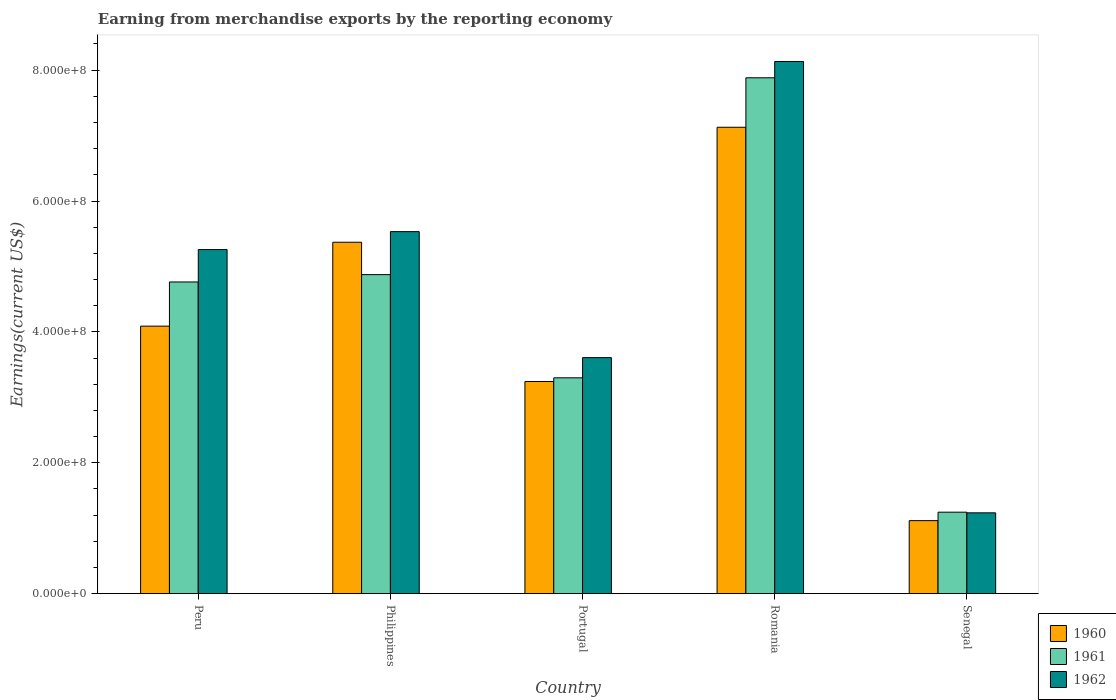Are the number of bars on each tick of the X-axis equal?
Make the answer very short. Yes. How many bars are there on the 2nd tick from the right?
Your answer should be very brief. 3. In how many cases, is the number of bars for a given country not equal to the number of legend labels?
Provide a succinct answer. 0. What is the amount earned from merchandise exports in 1962 in Senegal?
Your answer should be very brief. 1.24e+08. Across all countries, what is the maximum amount earned from merchandise exports in 1961?
Provide a short and direct response. 7.88e+08. Across all countries, what is the minimum amount earned from merchandise exports in 1962?
Your answer should be compact. 1.24e+08. In which country was the amount earned from merchandise exports in 1961 maximum?
Keep it short and to the point. Romania. In which country was the amount earned from merchandise exports in 1962 minimum?
Make the answer very short. Senegal. What is the total amount earned from merchandise exports in 1962 in the graph?
Ensure brevity in your answer.  2.38e+09. What is the difference between the amount earned from merchandise exports in 1960 in Peru and that in Portugal?
Give a very brief answer. 8.46e+07. What is the difference between the amount earned from merchandise exports in 1961 in Peru and the amount earned from merchandise exports in 1962 in Romania?
Give a very brief answer. -3.37e+08. What is the average amount earned from merchandise exports in 1961 per country?
Your answer should be compact. 4.41e+08. What is the difference between the amount earned from merchandise exports of/in 1960 and amount earned from merchandise exports of/in 1961 in Senegal?
Make the answer very short. -1.29e+07. In how many countries, is the amount earned from merchandise exports in 1960 greater than 520000000 US$?
Provide a succinct answer. 2. What is the ratio of the amount earned from merchandise exports in 1962 in Peru to that in Senegal?
Provide a succinct answer. 4.26. Is the amount earned from merchandise exports in 1960 in Peru less than that in Senegal?
Your answer should be very brief. No. Is the difference between the amount earned from merchandise exports in 1960 in Peru and Romania greater than the difference between the amount earned from merchandise exports in 1961 in Peru and Romania?
Ensure brevity in your answer.  Yes. What is the difference between the highest and the second highest amount earned from merchandise exports in 1962?
Provide a succinct answer. 2.87e+08. What is the difference between the highest and the lowest amount earned from merchandise exports in 1962?
Your answer should be very brief. 6.90e+08. In how many countries, is the amount earned from merchandise exports in 1961 greater than the average amount earned from merchandise exports in 1961 taken over all countries?
Give a very brief answer. 3. Is the sum of the amount earned from merchandise exports in 1962 in Peru and Senegal greater than the maximum amount earned from merchandise exports in 1960 across all countries?
Provide a short and direct response. No. What does the 3rd bar from the right in Peru represents?
Your answer should be very brief. 1960. Is it the case that in every country, the sum of the amount earned from merchandise exports in 1962 and amount earned from merchandise exports in 1960 is greater than the amount earned from merchandise exports in 1961?
Offer a very short reply. Yes. Are all the bars in the graph horizontal?
Provide a short and direct response. No. How many countries are there in the graph?
Ensure brevity in your answer.  5. Are the values on the major ticks of Y-axis written in scientific E-notation?
Offer a very short reply. Yes. Does the graph contain any zero values?
Provide a short and direct response. No. Where does the legend appear in the graph?
Your answer should be very brief. Bottom right. How many legend labels are there?
Provide a short and direct response. 3. How are the legend labels stacked?
Provide a succinct answer. Vertical. What is the title of the graph?
Offer a terse response. Earning from merchandise exports by the reporting economy. Does "2012" appear as one of the legend labels in the graph?
Your response must be concise. No. What is the label or title of the X-axis?
Your answer should be compact. Country. What is the label or title of the Y-axis?
Give a very brief answer. Earnings(current US$). What is the Earnings(current US$) in 1960 in Peru?
Your answer should be compact. 4.09e+08. What is the Earnings(current US$) of 1961 in Peru?
Make the answer very short. 4.76e+08. What is the Earnings(current US$) of 1962 in Peru?
Your answer should be compact. 5.26e+08. What is the Earnings(current US$) of 1960 in Philippines?
Your answer should be very brief. 5.37e+08. What is the Earnings(current US$) in 1961 in Philippines?
Provide a short and direct response. 4.88e+08. What is the Earnings(current US$) in 1962 in Philippines?
Give a very brief answer. 5.53e+08. What is the Earnings(current US$) in 1960 in Portugal?
Offer a very short reply. 3.24e+08. What is the Earnings(current US$) of 1961 in Portugal?
Make the answer very short. 3.30e+08. What is the Earnings(current US$) of 1962 in Portugal?
Keep it short and to the point. 3.61e+08. What is the Earnings(current US$) in 1960 in Romania?
Offer a very short reply. 7.13e+08. What is the Earnings(current US$) in 1961 in Romania?
Provide a succinct answer. 7.88e+08. What is the Earnings(current US$) in 1962 in Romania?
Ensure brevity in your answer.  8.13e+08. What is the Earnings(current US$) of 1960 in Senegal?
Make the answer very short. 1.12e+08. What is the Earnings(current US$) in 1961 in Senegal?
Offer a very short reply. 1.24e+08. What is the Earnings(current US$) in 1962 in Senegal?
Your answer should be very brief. 1.24e+08. Across all countries, what is the maximum Earnings(current US$) of 1960?
Offer a very short reply. 7.13e+08. Across all countries, what is the maximum Earnings(current US$) in 1961?
Provide a short and direct response. 7.88e+08. Across all countries, what is the maximum Earnings(current US$) in 1962?
Provide a succinct answer. 8.13e+08. Across all countries, what is the minimum Earnings(current US$) in 1960?
Make the answer very short. 1.12e+08. Across all countries, what is the minimum Earnings(current US$) of 1961?
Your response must be concise. 1.24e+08. Across all countries, what is the minimum Earnings(current US$) of 1962?
Offer a very short reply. 1.24e+08. What is the total Earnings(current US$) of 1960 in the graph?
Offer a very short reply. 2.09e+09. What is the total Earnings(current US$) of 1961 in the graph?
Your answer should be compact. 2.21e+09. What is the total Earnings(current US$) of 1962 in the graph?
Make the answer very short. 2.38e+09. What is the difference between the Earnings(current US$) of 1960 in Peru and that in Philippines?
Ensure brevity in your answer.  -1.28e+08. What is the difference between the Earnings(current US$) in 1961 in Peru and that in Philippines?
Provide a succinct answer. -1.12e+07. What is the difference between the Earnings(current US$) of 1962 in Peru and that in Philippines?
Your response must be concise. -2.74e+07. What is the difference between the Earnings(current US$) in 1960 in Peru and that in Portugal?
Ensure brevity in your answer.  8.46e+07. What is the difference between the Earnings(current US$) in 1961 in Peru and that in Portugal?
Your response must be concise. 1.46e+08. What is the difference between the Earnings(current US$) in 1962 in Peru and that in Portugal?
Your answer should be compact. 1.65e+08. What is the difference between the Earnings(current US$) of 1960 in Peru and that in Romania?
Your answer should be compact. -3.04e+08. What is the difference between the Earnings(current US$) of 1961 in Peru and that in Romania?
Offer a very short reply. -3.12e+08. What is the difference between the Earnings(current US$) of 1962 in Peru and that in Romania?
Keep it short and to the point. -2.87e+08. What is the difference between the Earnings(current US$) of 1960 in Peru and that in Senegal?
Your answer should be compact. 2.97e+08. What is the difference between the Earnings(current US$) in 1961 in Peru and that in Senegal?
Your answer should be very brief. 3.52e+08. What is the difference between the Earnings(current US$) in 1962 in Peru and that in Senegal?
Ensure brevity in your answer.  4.02e+08. What is the difference between the Earnings(current US$) in 1960 in Philippines and that in Portugal?
Offer a very short reply. 2.13e+08. What is the difference between the Earnings(current US$) in 1961 in Philippines and that in Portugal?
Keep it short and to the point. 1.58e+08. What is the difference between the Earnings(current US$) in 1962 in Philippines and that in Portugal?
Offer a very short reply. 1.93e+08. What is the difference between the Earnings(current US$) of 1960 in Philippines and that in Romania?
Make the answer very short. -1.76e+08. What is the difference between the Earnings(current US$) in 1961 in Philippines and that in Romania?
Provide a short and direct response. -3.01e+08. What is the difference between the Earnings(current US$) of 1962 in Philippines and that in Romania?
Your response must be concise. -2.60e+08. What is the difference between the Earnings(current US$) of 1960 in Philippines and that in Senegal?
Ensure brevity in your answer.  4.25e+08. What is the difference between the Earnings(current US$) of 1961 in Philippines and that in Senegal?
Provide a succinct answer. 3.63e+08. What is the difference between the Earnings(current US$) in 1962 in Philippines and that in Senegal?
Keep it short and to the point. 4.30e+08. What is the difference between the Earnings(current US$) in 1960 in Portugal and that in Romania?
Provide a succinct answer. -3.89e+08. What is the difference between the Earnings(current US$) of 1961 in Portugal and that in Romania?
Your response must be concise. -4.58e+08. What is the difference between the Earnings(current US$) in 1962 in Portugal and that in Romania?
Provide a short and direct response. -4.53e+08. What is the difference between the Earnings(current US$) of 1960 in Portugal and that in Senegal?
Ensure brevity in your answer.  2.13e+08. What is the difference between the Earnings(current US$) of 1961 in Portugal and that in Senegal?
Your answer should be compact. 2.05e+08. What is the difference between the Earnings(current US$) in 1962 in Portugal and that in Senegal?
Offer a terse response. 2.37e+08. What is the difference between the Earnings(current US$) in 1960 in Romania and that in Senegal?
Your answer should be compact. 6.01e+08. What is the difference between the Earnings(current US$) of 1961 in Romania and that in Senegal?
Give a very brief answer. 6.64e+08. What is the difference between the Earnings(current US$) of 1962 in Romania and that in Senegal?
Your answer should be compact. 6.90e+08. What is the difference between the Earnings(current US$) of 1960 in Peru and the Earnings(current US$) of 1961 in Philippines?
Provide a succinct answer. -7.87e+07. What is the difference between the Earnings(current US$) in 1960 in Peru and the Earnings(current US$) in 1962 in Philippines?
Make the answer very short. -1.44e+08. What is the difference between the Earnings(current US$) of 1961 in Peru and the Earnings(current US$) of 1962 in Philippines?
Your answer should be very brief. -7.69e+07. What is the difference between the Earnings(current US$) of 1960 in Peru and the Earnings(current US$) of 1961 in Portugal?
Your response must be concise. 7.90e+07. What is the difference between the Earnings(current US$) in 1960 in Peru and the Earnings(current US$) in 1962 in Portugal?
Make the answer very short. 4.81e+07. What is the difference between the Earnings(current US$) in 1961 in Peru and the Earnings(current US$) in 1962 in Portugal?
Your answer should be compact. 1.16e+08. What is the difference between the Earnings(current US$) of 1960 in Peru and the Earnings(current US$) of 1961 in Romania?
Provide a succinct answer. -3.79e+08. What is the difference between the Earnings(current US$) of 1960 in Peru and the Earnings(current US$) of 1962 in Romania?
Provide a succinct answer. -4.04e+08. What is the difference between the Earnings(current US$) in 1961 in Peru and the Earnings(current US$) in 1962 in Romania?
Your answer should be very brief. -3.37e+08. What is the difference between the Earnings(current US$) of 1960 in Peru and the Earnings(current US$) of 1961 in Senegal?
Make the answer very short. 2.84e+08. What is the difference between the Earnings(current US$) in 1960 in Peru and the Earnings(current US$) in 1962 in Senegal?
Offer a very short reply. 2.85e+08. What is the difference between the Earnings(current US$) in 1961 in Peru and the Earnings(current US$) in 1962 in Senegal?
Your answer should be compact. 3.53e+08. What is the difference between the Earnings(current US$) in 1960 in Philippines and the Earnings(current US$) in 1961 in Portugal?
Provide a short and direct response. 2.07e+08. What is the difference between the Earnings(current US$) in 1960 in Philippines and the Earnings(current US$) in 1962 in Portugal?
Give a very brief answer. 1.76e+08. What is the difference between the Earnings(current US$) of 1961 in Philippines and the Earnings(current US$) of 1962 in Portugal?
Provide a short and direct response. 1.27e+08. What is the difference between the Earnings(current US$) of 1960 in Philippines and the Earnings(current US$) of 1961 in Romania?
Keep it short and to the point. -2.51e+08. What is the difference between the Earnings(current US$) of 1960 in Philippines and the Earnings(current US$) of 1962 in Romania?
Provide a short and direct response. -2.76e+08. What is the difference between the Earnings(current US$) of 1961 in Philippines and the Earnings(current US$) of 1962 in Romania?
Make the answer very short. -3.26e+08. What is the difference between the Earnings(current US$) of 1960 in Philippines and the Earnings(current US$) of 1961 in Senegal?
Your answer should be very brief. 4.12e+08. What is the difference between the Earnings(current US$) of 1960 in Philippines and the Earnings(current US$) of 1962 in Senegal?
Provide a succinct answer. 4.14e+08. What is the difference between the Earnings(current US$) of 1961 in Philippines and the Earnings(current US$) of 1962 in Senegal?
Ensure brevity in your answer.  3.64e+08. What is the difference between the Earnings(current US$) of 1960 in Portugal and the Earnings(current US$) of 1961 in Romania?
Your response must be concise. -4.64e+08. What is the difference between the Earnings(current US$) of 1960 in Portugal and the Earnings(current US$) of 1962 in Romania?
Make the answer very short. -4.89e+08. What is the difference between the Earnings(current US$) in 1961 in Portugal and the Earnings(current US$) in 1962 in Romania?
Your response must be concise. -4.83e+08. What is the difference between the Earnings(current US$) of 1960 in Portugal and the Earnings(current US$) of 1961 in Senegal?
Give a very brief answer. 2.00e+08. What is the difference between the Earnings(current US$) in 1960 in Portugal and the Earnings(current US$) in 1962 in Senegal?
Keep it short and to the point. 2.01e+08. What is the difference between the Earnings(current US$) in 1961 in Portugal and the Earnings(current US$) in 1962 in Senegal?
Keep it short and to the point. 2.06e+08. What is the difference between the Earnings(current US$) in 1960 in Romania and the Earnings(current US$) in 1961 in Senegal?
Keep it short and to the point. 5.88e+08. What is the difference between the Earnings(current US$) of 1960 in Romania and the Earnings(current US$) of 1962 in Senegal?
Provide a short and direct response. 5.89e+08. What is the difference between the Earnings(current US$) of 1961 in Romania and the Earnings(current US$) of 1962 in Senegal?
Offer a very short reply. 6.65e+08. What is the average Earnings(current US$) in 1960 per country?
Provide a short and direct response. 4.19e+08. What is the average Earnings(current US$) of 1961 per country?
Provide a succinct answer. 4.41e+08. What is the average Earnings(current US$) in 1962 per country?
Provide a short and direct response. 4.75e+08. What is the difference between the Earnings(current US$) of 1960 and Earnings(current US$) of 1961 in Peru?
Your answer should be compact. -6.75e+07. What is the difference between the Earnings(current US$) of 1960 and Earnings(current US$) of 1962 in Peru?
Offer a very short reply. -1.17e+08. What is the difference between the Earnings(current US$) of 1961 and Earnings(current US$) of 1962 in Peru?
Provide a short and direct response. -4.95e+07. What is the difference between the Earnings(current US$) of 1960 and Earnings(current US$) of 1961 in Philippines?
Provide a short and direct response. 4.95e+07. What is the difference between the Earnings(current US$) of 1960 and Earnings(current US$) of 1962 in Philippines?
Provide a succinct answer. -1.62e+07. What is the difference between the Earnings(current US$) of 1961 and Earnings(current US$) of 1962 in Philippines?
Give a very brief answer. -6.57e+07. What is the difference between the Earnings(current US$) of 1960 and Earnings(current US$) of 1961 in Portugal?
Make the answer very short. -5.62e+06. What is the difference between the Earnings(current US$) in 1960 and Earnings(current US$) in 1962 in Portugal?
Your response must be concise. -3.65e+07. What is the difference between the Earnings(current US$) in 1961 and Earnings(current US$) in 1962 in Portugal?
Your answer should be compact. -3.09e+07. What is the difference between the Earnings(current US$) of 1960 and Earnings(current US$) of 1961 in Romania?
Ensure brevity in your answer.  -7.56e+07. What is the difference between the Earnings(current US$) in 1960 and Earnings(current US$) in 1962 in Romania?
Provide a short and direct response. -1.01e+08. What is the difference between the Earnings(current US$) in 1961 and Earnings(current US$) in 1962 in Romania?
Ensure brevity in your answer.  -2.49e+07. What is the difference between the Earnings(current US$) in 1960 and Earnings(current US$) in 1961 in Senegal?
Keep it short and to the point. -1.29e+07. What is the difference between the Earnings(current US$) of 1960 and Earnings(current US$) of 1962 in Senegal?
Provide a short and direct response. -1.19e+07. What is the ratio of the Earnings(current US$) of 1960 in Peru to that in Philippines?
Make the answer very short. 0.76. What is the ratio of the Earnings(current US$) in 1962 in Peru to that in Philippines?
Your answer should be compact. 0.95. What is the ratio of the Earnings(current US$) in 1960 in Peru to that in Portugal?
Make the answer very short. 1.26. What is the ratio of the Earnings(current US$) of 1961 in Peru to that in Portugal?
Your answer should be very brief. 1.44. What is the ratio of the Earnings(current US$) of 1962 in Peru to that in Portugal?
Offer a terse response. 1.46. What is the ratio of the Earnings(current US$) in 1960 in Peru to that in Romania?
Ensure brevity in your answer.  0.57. What is the ratio of the Earnings(current US$) of 1961 in Peru to that in Romania?
Your response must be concise. 0.6. What is the ratio of the Earnings(current US$) in 1962 in Peru to that in Romania?
Keep it short and to the point. 0.65. What is the ratio of the Earnings(current US$) in 1960 in Peru to that in Senegal?
Keep it short and to the point. 3.66. What is the ratio of the Earnings(current US$) of 1961 in Peru to that in Senegal?
Ensure brevity in your answer.  3.83. What is the ratio of the Earnings(current US$) of 1962 in Peru to that in Senegal?
Give a very brief answer. 4.26. What is the ratio of the Earnings(current US$) in 1960 in Philippines to that in Portugal?
Provide a short and direct response. 1.66. What is the ratio of the Earnings(current US$) of 1961 in Philippines to that in Portugal?
Make the answer very short. 1.48. What is the ratio of the Earnings(current US$) in 1962 in Philippines to that in Portugal?
Provide a short and direct response. 1.53. What is the ratio of the Earnings(current US$) in 1960 in Philippines to that in Romania?
Provide a short and direct response. 0.75. What is the ratio of the Earnings(current US$) of 1961 in Philippines to that in Romania?
Offer a very short reply. 0.62. What is the ratio of the Earnings(current US$) in 1962 in Philippines to that in Romania?
Give a very brief answer. 0.68. What is the ratio of the Earnings(current US$) in 1960 in Philippines to that in Senegal?
Your answer should be compact. 4.81. What is the ratio of the Earnings(current US$) of 1961 in Philippines to that in Senegal?
Offer a very short reply. 3.92. What is the ratio of the Earnings(current US$) of 1962 in Philippines to that in Senegal?
Provide a succinct answer. 4.48. What is the ratio of the Earnings(current US$) in 1960 in Portugal to that in Romania?
Provide a succinct answer. 0.45. What is the ratio of the Earnings(current US$) of 1961 in Portugal to that in Romania?
Make the answer very short. 0.42. What is the ratio of the Earnings(current US$) in 1962 in Portugal to that in Romania?
Provide a succinct answer. 0.44. What is the ratio of the Earnings(current US$) of 1960 in Portugal to that in Senegal?
Make the answer very short. 2.9. What is the ratio of the Earnings(current US$) in 1961 in Portugal to that in Senegal?
Your answer should be very brief. 2.65. What is the ratio of the Earnings(current US$) of 1962 in Portugal to that in Senegal?
Ensure brevity in your answer.  2.92. What is the ratio of the Earnings(current US$) of 1960 in Romania to that in Senegal?
Give a very brief answer. 6.39. What is the ratio of the Earnings(current US$) in 1961 in Romania to that in Senegal?
Give a very brief answer. 6.33. What is the ratio of the Earnings(current US$) of 1962 in Romania to that in Senegal?
Provide a succinct answer. 6.58. What is the difference between the highest and the second highest Earnings(current US$) in 1960?
Your response must be concise. 1.76e+08. What is the difference between the highest and the second highest Earnings(current US$) of 1961?
Give a very brief answer. 3.01e+08. What is the difference between the highest and the second highest Earnings(current US$) of 1962?
Provide a short and direct response. 2.60e+08. What is the difference between the highest and the lowest Earnings(current US$) of 1960?
Make the answer very short. 6.01e+08. What is the difference between the highest and the lowest Earnings(current US$) in 1961?
Keep it short and to the point. 6.64e+08. What is the difference between the highest and the lowest Earnings(current US$) in 1962?
Ensure brevity in your answer.  6.90e+08. 